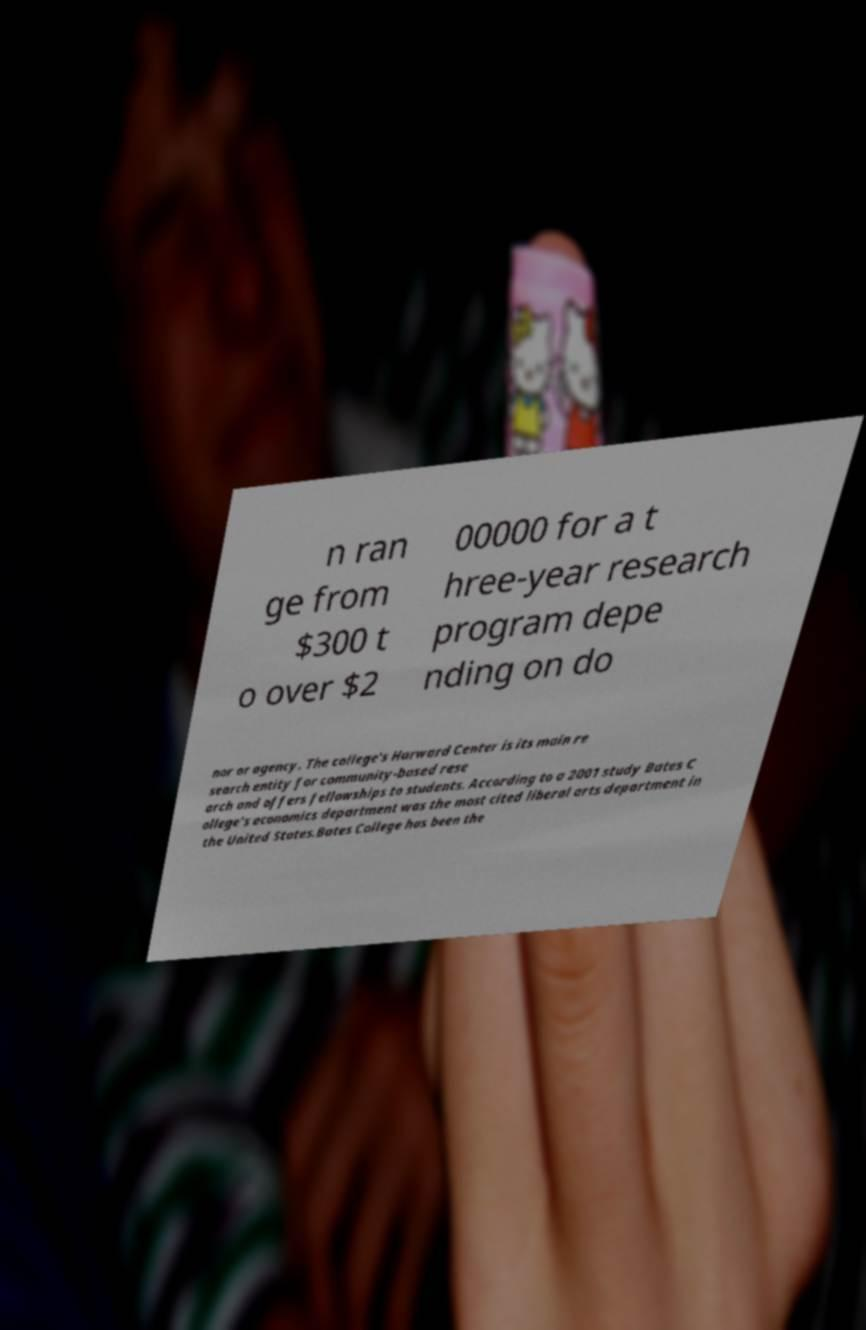Can you read and provide the text displayed in the image?This photo seems to have some interesting text. Can you extract and type it out for me? n ran ge from $300 t o over $2 00000 for a t hree-year research program depe nding on do nor or agency. The college's Harward Center is its main re search entity for community-based rese arch and offers fellowships to students. According to a 2001 study Bates C ollege's economics department was the most cited liberal arts department in the United States.Bates College has been the 